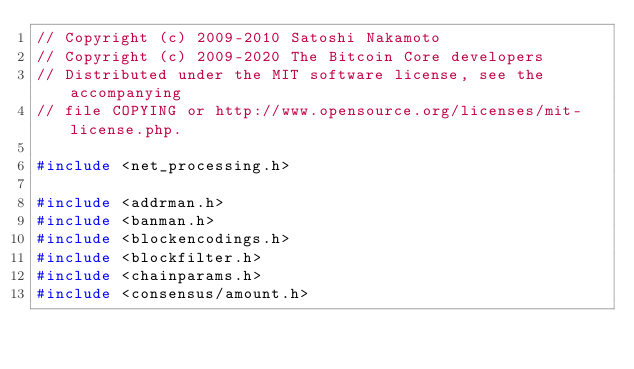Convert code to text. <code><loc_0><loc_0><loc_500><loc_500><_C++_>// Copyright (c) 2009-2010 Satoshi Nakamoto
// Copyright (c) 2009-2020 The Bitcoin Core developers
// Distributed under the MIT software license, see the accompanying
// file COPYING or http://www.opensource.org/licenses/mit-license.php.

#include <net_processing.h>

#include <addrman.h>
#include <banman.h>
#include <blockencodings.h>
#include <blockfilter.h>
#include <chainparams.h>
#include <consensus/amount.h></code> 